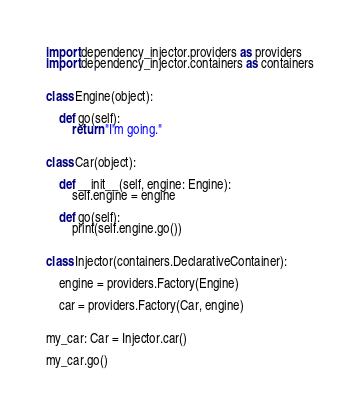Convert code to text. <code><loc_0><loc_0><loc_500><loc_500><_Python_>import dependency_injector.providers as providers
import dependency_injector.containers as containers


class Engine(object):

    def go(self):
        return "I'm going."


class Car(object):

    def __init__(self, engine: Engine):
        self.engine = engine

    def go(self):
        print(self.engine.go())


class Injector(containers.DeclarativeContainer):

    engine = providers.Factory(Engine)

    car = providers.Factory(Car, engine)


my_car: Car = Injector.car()

my_car.go()
</code> 